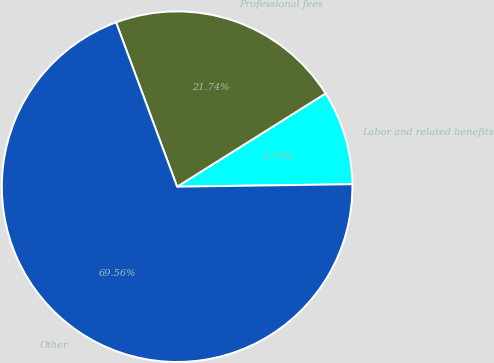<chart> <loc_0><loc_0><loc_500><loc_500><pie_chart><fcel>Labor and related benefits<fcel>Professional fees<fcel>Other<nl><fcel>8.7%<fcel>21.74%<fcel>69.57%<nl></chart> 